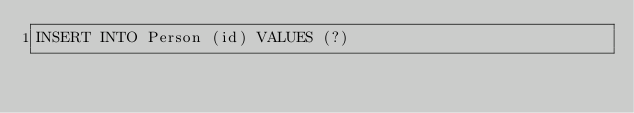Convert code to text. <code><loc_0><loc_0><loc_500><loc_500><_SQL_>INSERT INTO Person (id) VALUES (?)</code> 